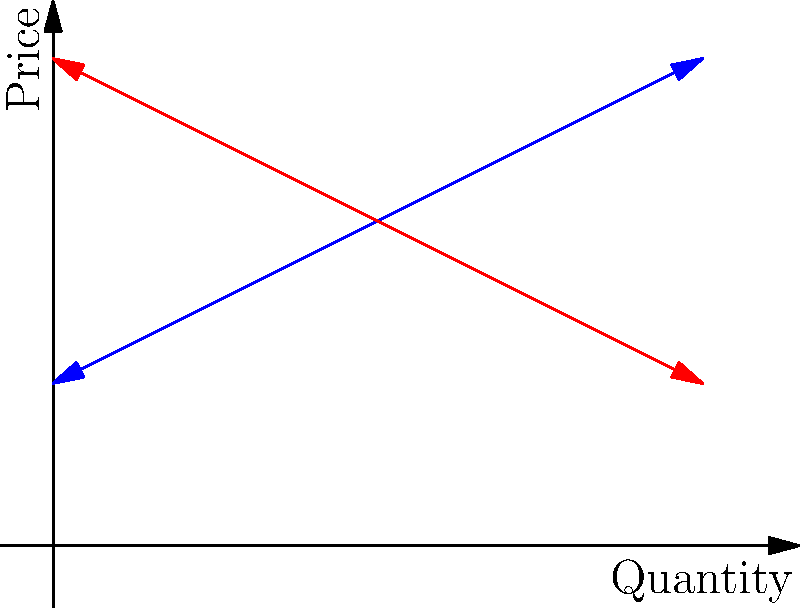Consider the supply and demand graph for a commodity market with a price floor implemented at $P_f = 12$. How does this price floor affect the market equilibrium, and what economic inefficiencies arise as a result? To analyze the impact of the price floor, let's follow these steps:

1) First, identify the market equilibrium without the price floor:
   - The equilibrium point E is where supply (S) and demand (D) curves intersect.
   - The equilibrium price is $P_e = 10$ and the equilibrium quantity is $Q_e = 10$.

2) Now, consider the price floor at $P_f = 12$:
   - The price floor is above the equilibrium price, so it is binding.
   - The market price cannot fall below $P_f = 12$.

3) At $P_f = 12$:
   - Quantity supplied: $Q_s = 14$ (producers are willing to supply more at a higher price)
   - Quantity demanded: $Q_d = 6$ (consumers demand less at a higher price)

4) Economic inefficiencies:
   a) Surplus: $Q_s - Q_d = 14 - 6 = 8$ units
      - This surplus represents overproduction and wasted resources.
   
   b) Deadweight loss: 
      - This is represented by the triangular area between the supply and demand curves, from $Q_d$ to $Q_e$.
      - It represents the loss of economic efficiency due to the price floor.

   c) Allocative inefficiency:
      - The price signal is distorted, leading to misallocation of resources.
      - Some consumers who value the good above $P_e$ but below $P_f$ are priced out of the market.

5) Other effects:
   - Producers gain: area between $P_f$ and $P_e$, from 0 to $Q_d$.
   - Consumers lose: area between $P_f$ and $P_e$, from 0 to $Q_d$, plus part of the deadweight loss triangle.

In summary, the price floor creates a surplus, causes deadweight loss, and results in allocative inefficiency in the market.
Answer: The price floor creates a surplus of 8 units, causes deadweight loss, and results in allocative inefficiency. 